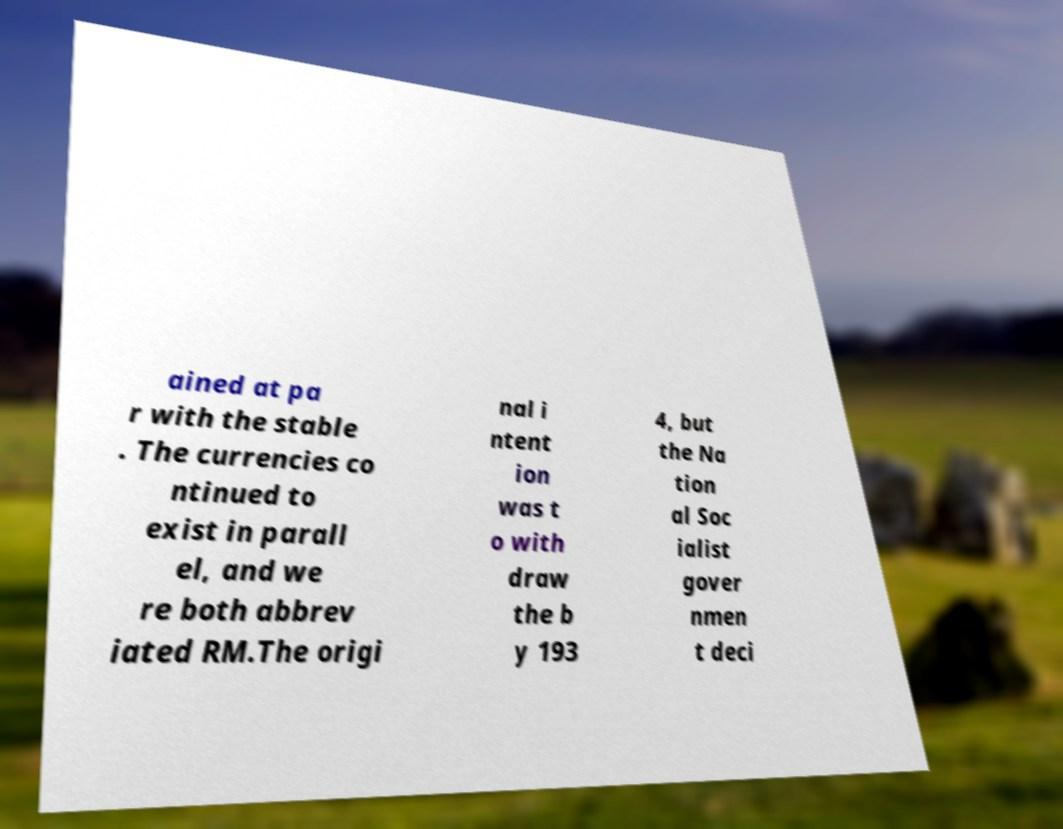Could you extract and type out the text from this image? ained at pa r with the stable . The currencies co ntinued to exist in parall el, and we re both abbrev iated RM.The origi nal i ntent ion was t o with draw the b y 193 4, but the Na tion al Soc ialist gover nmen t deci 